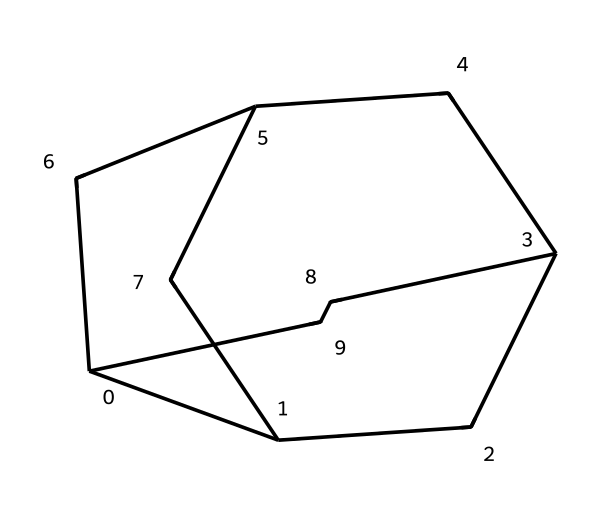What is the chemical name of this compound? The SMILES representation corresponds to adamantane, a well-known cage compound with a rigid polycyclic structure comprising carbon atoms.
Answer: adamantane How many carbon atoms are present in the structure? By analyzing the SMILES notation, we can count the number of unique carbon atoms represented. In this case, there are 10 carbon atoms in the structure.
Answer: 10 What type of structure does adamantane represent? Adamantane is classified as a cage compound, characterized by a highly symmetrical and three-dimensional arrangement of carbon atoms, which creates a compact structure.
Answer: cage compound What is the degree of saturation in this compound? Given that all carbons are connected with single bonds and form a cycloalkane structure, adamantane is fully saturated, meaning it does not have any double or triple bonds.
Answer: saturated How many hydrogen atoms are attached to the carbon structure? For adamantane, each carbon typically connects to enough hydrogen to satisfy its tetravalency. Considering the molecular structure, there are 16 hydrogen atoms in total.
Answer: 16 Which feature of adamantane makes it useful in the fragrance industry? The rigid and stable structure of adamantane leads to high volatility and persistence in fragrances, contributing to their longevity and scent profile in perfumes.
Answer: stability How does the cage structure affect the odor profile of adamantane-based fragrances? The unique cage structure restricts the movement of the molecules, which can lead to slower evaporation rates and more sustained fragrance duration, enhancing the olfactory experience.
Answer: sustained duration 